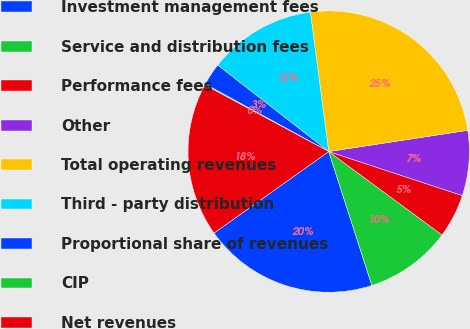Convert chart. <chart><loc_0><loc_0><loc_500><loc_500><pie_chart><fcel>Investment management fees<fcel>Service and distribution fees<fcel>Performance fees<fcel>Other<fcel>Total operating revenues<fcel>Third - party distribution<fcel>Proportional share of revenues<fcel>CIP<fcel>Net revenues<nl><fcel>20.13%<fcel>9.94%<fcel>5.03%<fcel>7.48%<fcel>24.67%<fcel>12.39%<fcel>2.57%<fcel>0.12%<fcel>17.68%<nl></chart> 